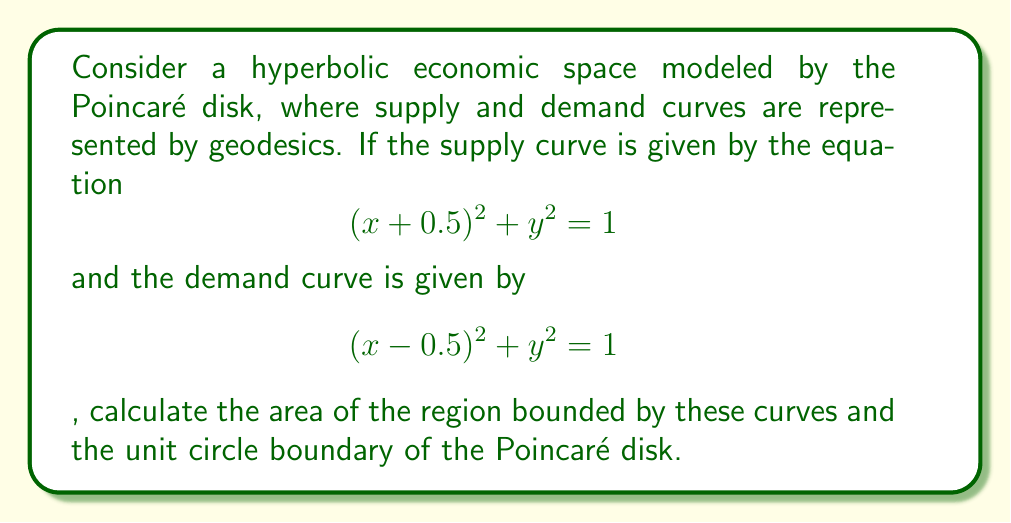Show me your answer to this math problem. 1) In the Poincaré disk model, geodesics are represented by circular arcs perpendicular to the boundary circle. The given equations represent such arcs.

2) The supply and demand curves intersect at two points. To find these, we solve:
   $$(x+0.5)^2 + y^2 = 1$$
   $$(x-0.5)^2 + y^2 = 1$$

   Subtracting these equations:
   $(x+0.5)^2 - (x-0.5)^2 = 0$
   $x^2 + x + 0.25 - (x^2 - x + 0.25) = 0$
   $2x = 0$
   $x = 0$

   Substituting back:
   $y^2 = 1 - (0+0.5)^2 = 0.75$
   $y = \pm \sqrt{0.75} = \pm \frac{\sqrt{3}}{2}$

3) The intersection points are $(0, \frac{\sqrt{3}}{2})$ and $(0, -\frac{\sqrt{3}}{2})$.

4) The area in the Poincaré disk is given by the formula:
   $$A = 4\pi - 2(\alpha + \beta + \gamma)$$
   where $\alpha$, $\beta$, and $\gamma$ are the angles at the vertices of the triangle formed.

5) Due to symmetry, we can calculate half the area and double it. Consider the triangle formed by the points $(0, \frac{\sqrt{3}}{2})$, $(0.5, 0)$, and $(-0.5, 0)$.

6) The angles can be calculated using the formula:
   $$\cos \theta = \frac{|z_1 - z_2||z_3 - z_4|}{|z_1 - z_3||z_2 - z_4|}$$
   where $z_1$, $z_2$, $z_3$, $z_4$ are the complex representations of the endpoints of the geodesics.

7) Calculating the angles:
   At $(0, \frac{\sqrt{3}}{2})$: $\theta_1 = \arccos(\frac{1}{2}) = \frac{\pi}{3}$
   At $(0.5, 0)$ and $(-0.5, 0)$: $\theta_2 = \theta_3 = \arccos(\frac{\sqrt{3}}{2}) = \frac{\pi}{6}$

8) The area of half the region is:
   $$A_{\text{half}} = 2\pi - 2(\frac{\pi}{3} + \frac{\pi}{6} + \frac{\pi}{6}) = \pi - \frac{4\pi}{3} = -\frac{\pi}{3}$$

9) The total area is:
   $$A_{\text{total}} = 2A_{\text{half}} = -\frac{2\pi}{3}$$
Answer: $-\frac{2\pi}{3}$ 